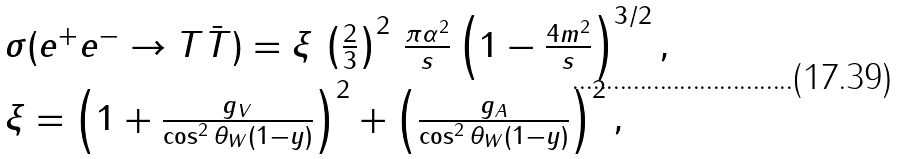<formula> <loc_0><loc_0><loc_500><loc_500>\begin{array} { l } \sigma ( e ^ { + } e ^ { - } \rightarrow T \bar { T } ) = \xi \, \left ( \frac { 2 } { 3 } \right ) ^ { 2 } \, \frac { \pi \alpha ^ { 2 } } { s } \left ( 1 - \frac { 4 m ^ { 2 } } { s } \right ) ^ { 3 / 2 } , \\ \xi = \left ( 1 + \frac { g _ { V } } { \cos ^ { 2 } \theta _ { W } ( 1 - y ) } \right ) ^ { 2 } + \left ( \frac { g _ { A } } { \cos ^ { 2 } \theta _ { W } ( 1 - y ) } \right ) ^ { 2 } , \end{array}</formula> 